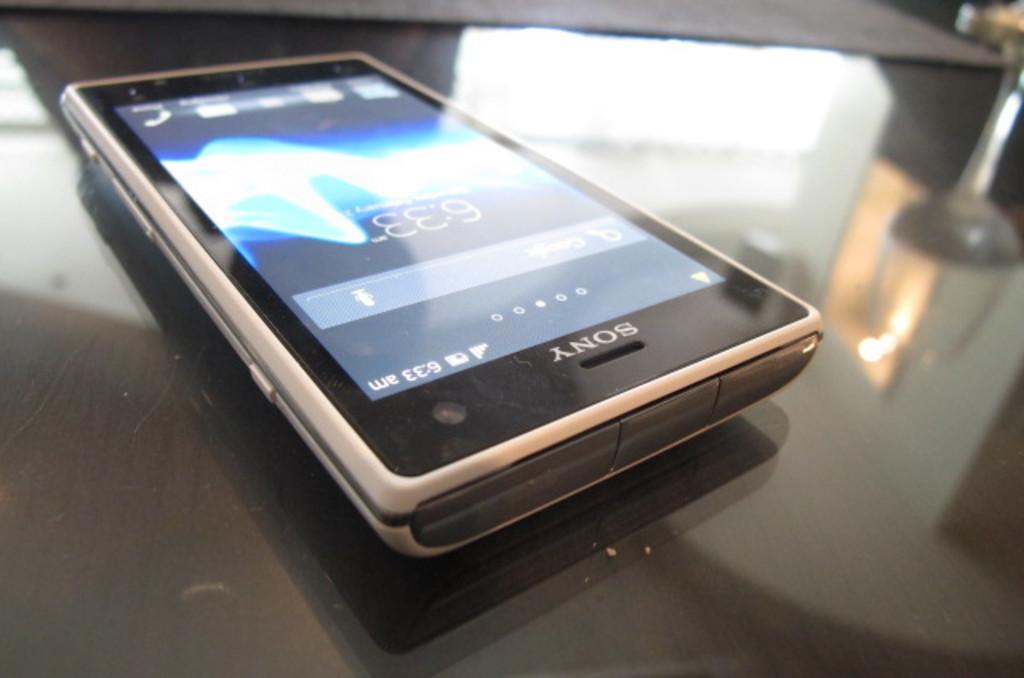<image>
Render a clear and concise summary of the photo. A Sony phone sits alone on a black table. 